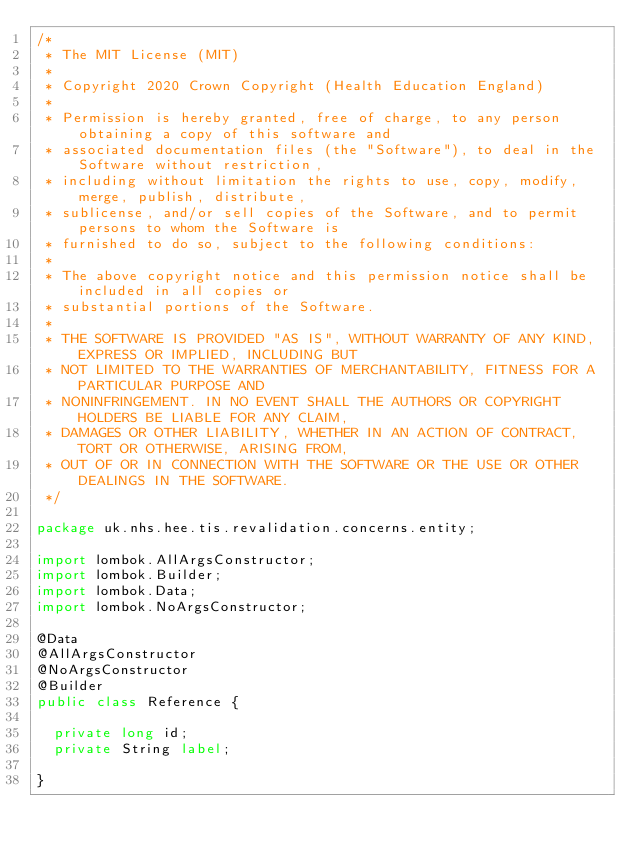Convert code to text. <code><loc_0><loc_0><loc_500><loc_500><_Java_>/*
 * The MIT License (MIT)
 *
 * Copyright 2020 Crown Copyright (Health Education England)
 *
 * Permission is hereby granted, free of charge, to any person obtaining a copy of this software and
 * associated documentation files (the "Software"), to deal in the Software without restriction,
 * including without limitation the rights to use, copy, modify, merge, publish, distribute,
 * sublicense, and/or sell copies of the Software, and to permit persons to whom the Software is
 * furnished to do so, subject to the following conditions:
 *
 * The above copyright notice and this permission notice shall be included in all copies or
 * substantial portions of the Software.
 *
 * THE SOFTWARE IS PROVIDED "AS IS", WITHOUT WARRANTY OF ANY KIND, EXPRESS OR IMPLIED, INCLUDING BUT
 * NOT LIMITED TO THE WARRANTIES OF MERCHANTABILITY, FITNESS FOR A PARTICULAR PURPOSE AND
 * NONINFRINGEMENT. IN NO EVENT SHALL THE AUTHORS OR COPYRIGHT HOLDERS BE LIABLE FOR ANY CLAIM,
 * DAMAGES OR OTHER LIABILITY, WHETHER IN AN ACTION OF CONTRACT, TORT OR OTHERWISE, ARISING FROM,
 * OUT OF OR IN CONNECTION WITH THE SOFTWARE OR THE USE OR OTHER DEALINGS IN THE SOFTWARE.
 */

package uk.nhs.hee.tis.revalidation.concerns.entity;

import lombok.AllArgsConstructor;
import lombok.Builder;
import lombok.Data;
import lombok.NoArgsConstructor;

@Data
@AllArgsConstructor
@NoArgsConstructor
@Builder
public class Reference {

  private long id;
  private String label;

}
</code> 